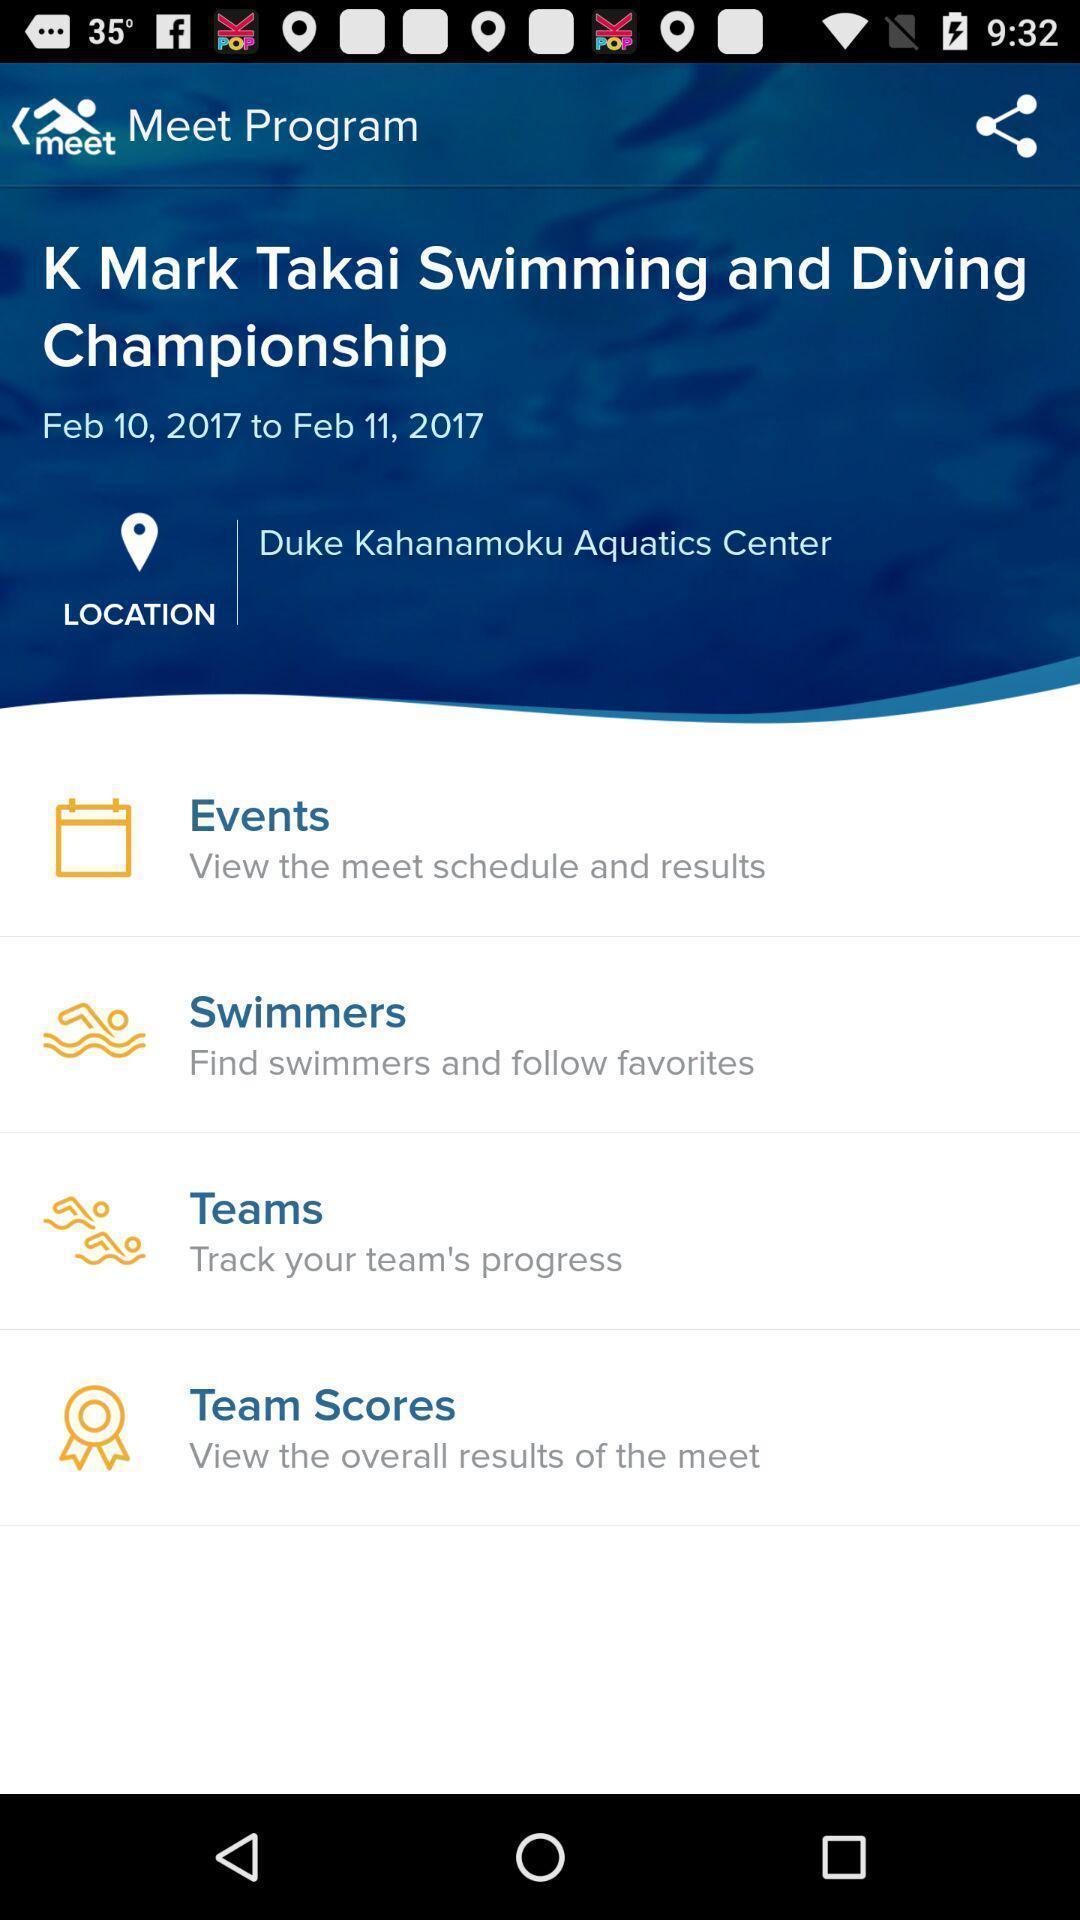Please provide a description for this image. Screen shows about an event planning app. 